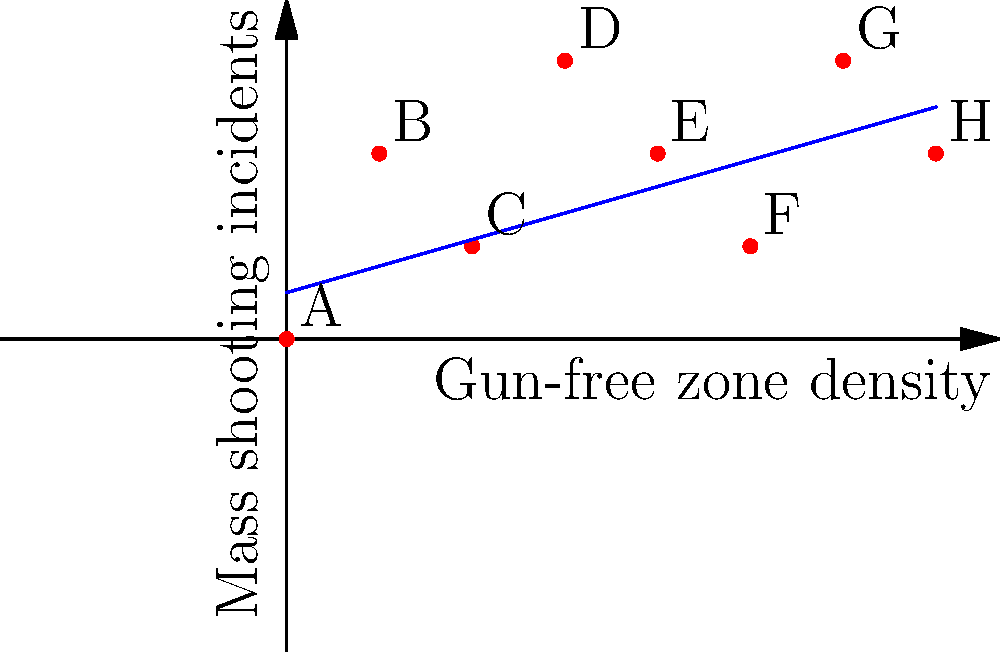Based on the graph showing the relationship between gun-free zone density and mass shooting incidents, which point represents the strongest evidence against the claim that gun-free zones attract mass shootings? To answer this question, we need to analyze the graph and understand what it represents:

1. The x-axis represents the density of gun-free zones in an area.
2. The y-axis represents the number of mass shooting incidents.
3. Each point (A through H) represents a different location or study.
4. The blue line represents the general trend of the data.

The claim that gun-free zones attract mass shootings would suggest a positive correlation between gun-free zone density and mass shooting incidents. To find evidence against this claim, we need to look for points that deviate significantly from this expected trend.

Analyzing the points:
- Points A, B, D, and G generally follow the trend line, supporting the claim.
- Points C and F are slightly below the trend line but don't strongly contradict it.
- Point E is above the trend line, which doesn't contradict the claim.
- Point H stands out as being significantly below the trend line.

Point H shows a high density of gun-free zones but a relatively low number of mass shooting incidents. This contradicts the expected relationship if gun-free zones were to attract mass shootings.

Therefore, Point H provides the strongest evidence against the claim that gun-free zones attract mass shootings.
Answer: Point H 